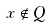<formula> <loc_0><loc_0><loc_500><loc_500>x \notin Q</formula> 